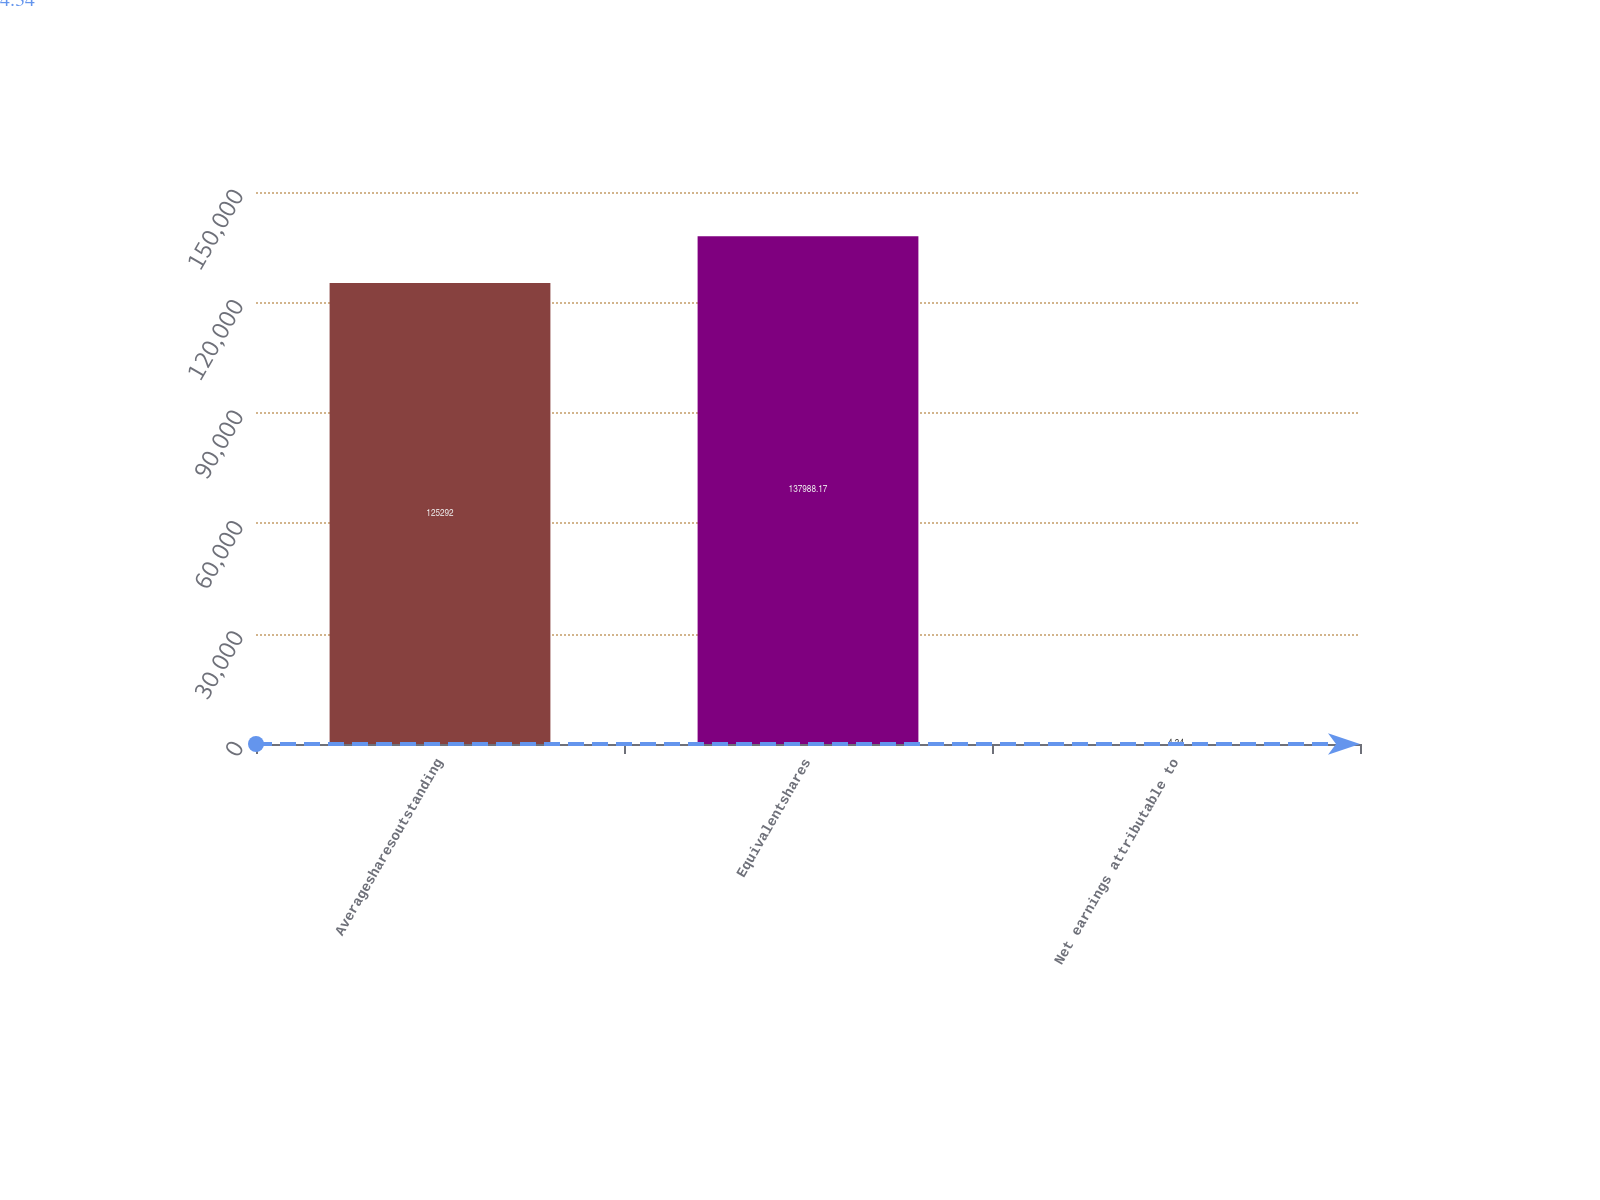<chart> <loc_0><loc_0><loc_500><loc_500><bar_chart><fcel>Averagesharesoutstanding<fcel>Equivalentshares<fcel>Net earnings attributable to<nl><fcel>125292<fcel>137988<fcel>4.34<nl></chart> 